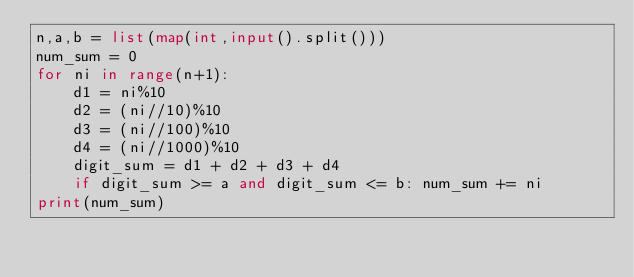<code> <loc_0><loc_0><loc_500><loc_500><_Python_>n,a,b = list(map(int,input().split()))
num_sum = 0
for ni in range(n+1):
    d1 = ni%10
    d2 = (ni//10)%10
    d3 = (ni//100)%10
    d4 = (ni//1000)%10
    digit_sum = d1 + d2 + d3 + d4
    if digit_sum >= a and digit_sum <= b: num_sum += ni
print(num_sum)</code> 